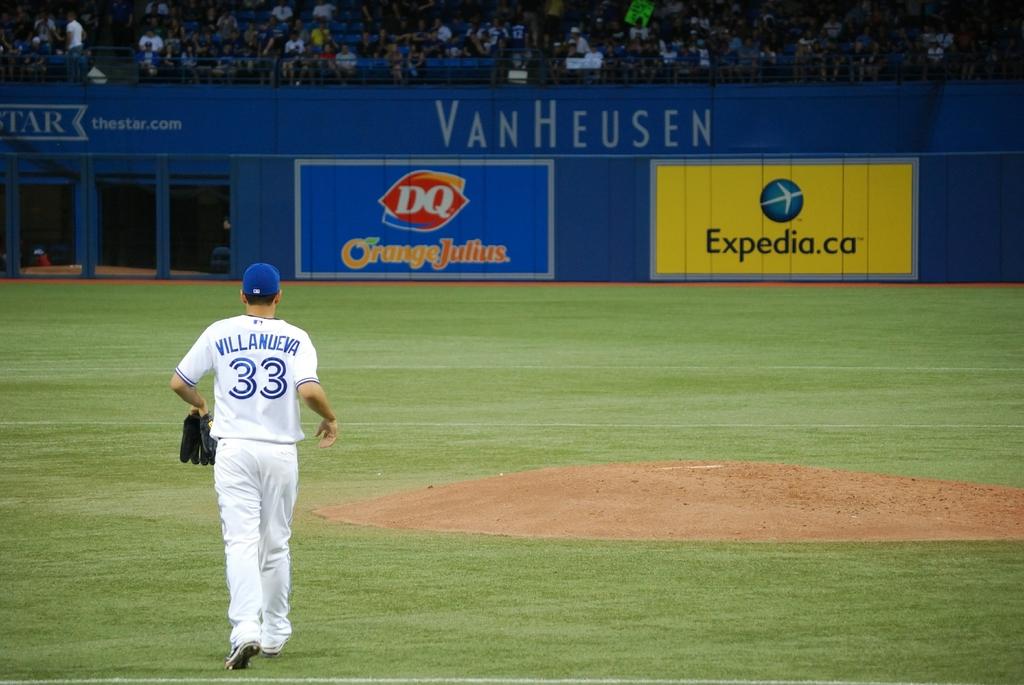What is the website on the yellow banner?
Make the answer very short. Expedia.ca. 